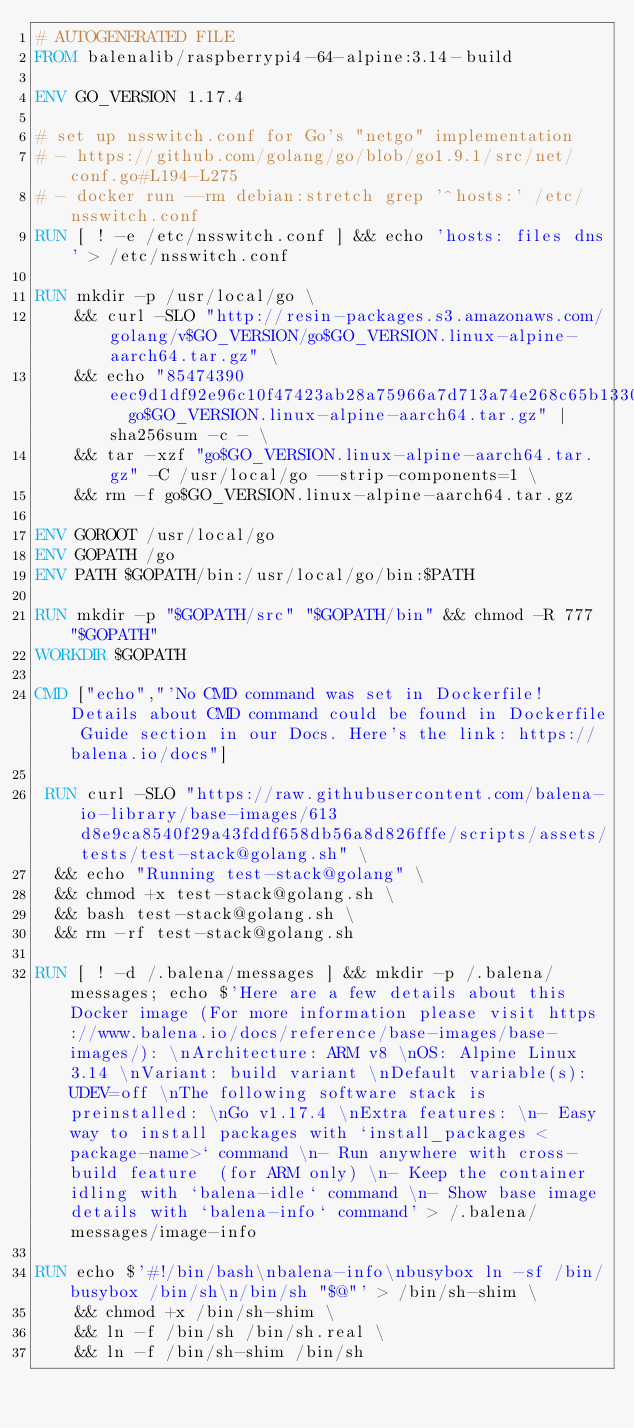Convert code to text. <code><loc_0><loc_0><loc_500><loc_500><_Dockerfile_># AUTOGENERATED FILE
FROM balenalib/raspberrypi4-64-alpine:3.14-build

ENV GO_VERSION 1.17.4

# set up nsswitch.conf for Go's "netgo" implementation
# - https://github.com/golang/go/blob/go1.9.1/src/net/conf.go#L194-L275
# - docker run --rm debian:stretch grep '^hosts:' /etc/nsswitch.conf
RUN [ ! -e /etc/nsswitch.conf ] && echo 'hosts: files dns' > /etc/nsswitch.conf

RUN mkdir -p /usr/local/go \
	&& curl -SLO "http://resin-packages.s3.amazonaws.com/golang/v$GO_VERSION/go$GO_VERSION.linux-alpine-aarch64.tar.gz" \
	&& echo "85474390eec9d1df92e96c10f47423ab28a75966a7d713a74e268c65b13309ef  go$GO_VERSION.linux-alpine-aarch64.tar.gz" | sha256sum -c - \
	&& tar -xzf "go$GO_VERSION.linux-alpine-aarch64.tar.gz" -C /usr/local/go --strip-components=1 \
	&& rm -f go$GO_VERSION.linux-alpine-aarch64.tar.gz

ENV GOROOT /usr/local/go
ENV GOPATH /go
ENV PATH $GOPATH/bin:/usr/local/go/bin:$PATH

RUN mkdir -p "$GOPATH/src" "$GOPATH/bin" && chmod -R 777 "$GOPATH"
WORKDIR $GOPATH

CMD ["echo","'No CMD command was set in Dockerfile! Details about CMD command could be found in Dockerfile Guide section in our Docs. Here's the link: https://balena.io/docs"]

 RUN curl -SLO "https://raw.githubusercontent.com/balena-io-library/base-images/613d8e9ca8540f29a43fddf658db56a8d826fffe/scripts/assets/tests/test-stack@golang.sh" \
  && echo "Running test-stack@golang" \
  && chmod +x test-stack@golang.sh \
  && bash test-stack@golang.sh \
  && rm -rf test-stack@golang.sh 

RUN [ ! -d /.balena/messages ] && mkdir -p /.balena/messages; echo $'Here are a few details about this Docker image (For more information please visit https://www.balena.io/docs/reference/base-images/base-images/): \nArchitecture: ARM v8 \nOS: Alpine Linux 3.14 \nVariant: build variant \nDefault variable(s): UDEV=off \nThe following software stack is preinstalled: \nGo v1.17.4 \nExtra features: \n- Easy way to install packages with `install_packages <package-name>` command \n- Run anywhere with cross-build feature  (for ARM only) \n- Keep the container idling with `balena-idle` command \n- Show base image details with `balena-info` command' > /.balena/messages/image-info

RUN echo $'#!/bin/bash\nbalena-info\nbusybox ln -sf /bin/busybox /bin/sh\n/bin/sh "$@"' > /bin/sh-shim \
	&& chmod +x /bin/sh-shim \
	&& ln -f /bin/sh /bin/sh.real \
	&& ln -f /bin/sh-shim /bin/sh</code> 